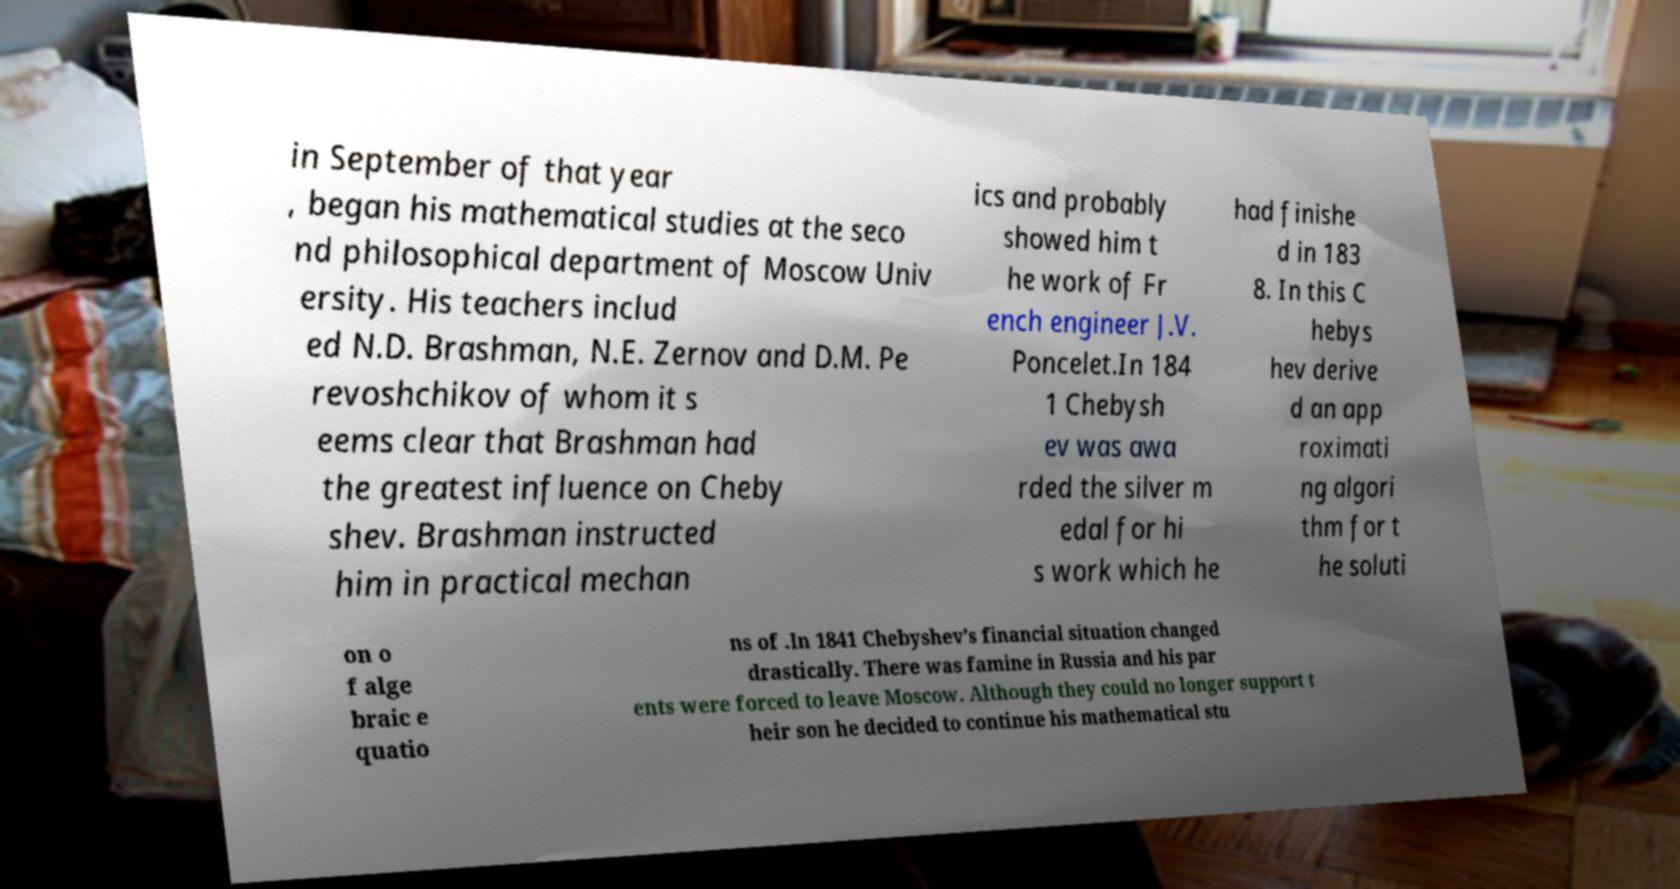Could you extract and type out the text from this image? in September of that year , began his mathematical studies at the seco nd philosophical department of Moscow Univ ersity. His teachers includ ed N.D. Brashman, N.E. Zernov and D.M. Pe revoshchikov of whom it s eems clear that Brashman had the greatest influence on Cheby shev. Brashman instructed him in practical mechan ics and probably showed him t he work of Fr ench engineer J.V. Poncelet.In 184 1 Chebysh ev was awa rded the silver m edal for hi s work which he had finishe d in 183 8. In this C hebys hev derive d an app roximati ng algori thm for t he soluti on o f alge braic e quatio ns of .In 1841 Chebyshev’s financial situation changed drastically. There was famine in Russia and his par ents were forced to leave Moscow. Although they could no longer support t heir son he decided to continue his mathematical stu 